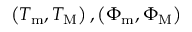<formula> <loc_0><loc_0><loc_500><loc_500>\left ( T _ { m } , T _ { M } \right ) , \left ( \Phi _ { m } , \Phi _ { M } \right )</formula> 